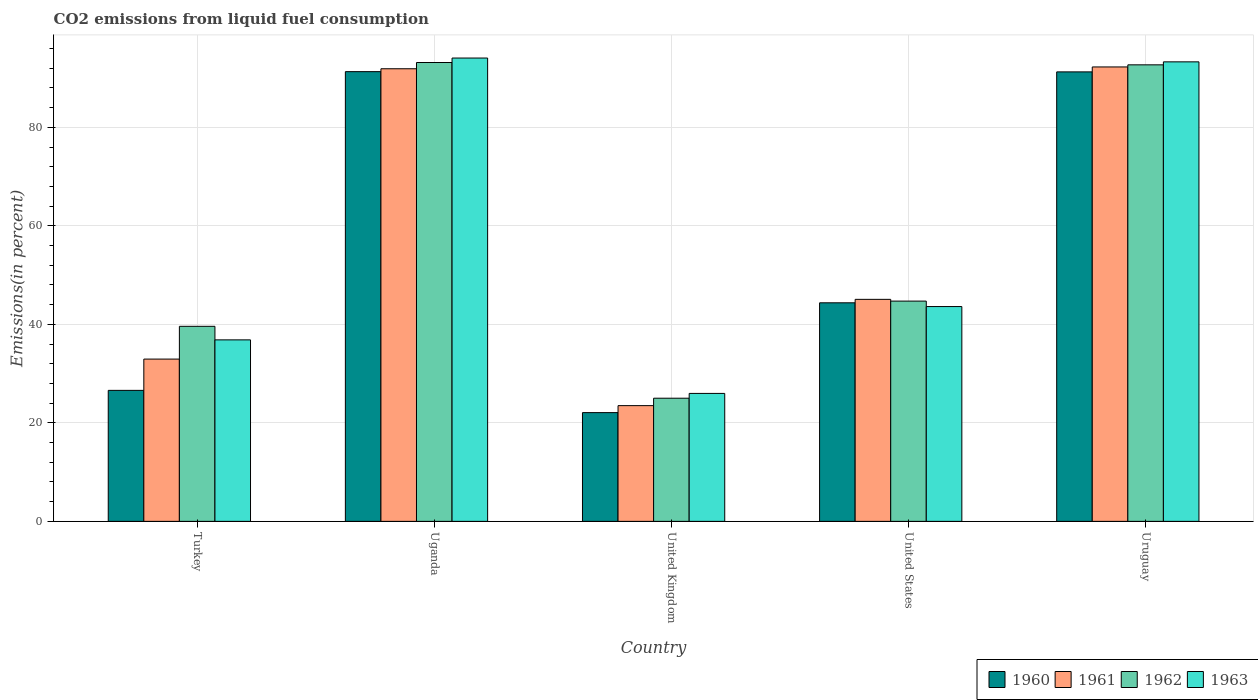How many different coloured bars are there?
Give a very brief answer. 4. Are the number of bars per tick equal to the number of legend labels?
Offer a very short reply. Yes. Are the number of bars on each tick of the X-axis equal?
Your answer should be compact. Yes. What is the label of the 2nd group of bars from the left?
Ensure brevity in your answer.  Uganda. What is the total CO2 emitted in 1963 in United Kingdom?
Your response must be concise. 25.98. Across all countries, what is the maximum total CO2 emitted in 1960?
Ensure brevity in your answer.  91.3. Across all countries, what is the minimum total CO2 emitted in 1963?
Ensure brevity in your answer.  25.98. In which country was the total CO2 emitted in 1961 maximum?
Give a very brief answer. Uruguay. In which country was the total CO2 emitted in 1960 minimum?
Your response must be concise. United Kingdom. What is the total total CO2 emitted in 1962 in the graph?
Ensure brevity in your answer.  295.17. What is the difference between the total CO2 emitted in 1960 in Turkey and that in Uganda?
Your response must be concise. -64.71. What is the difference between the total CO2 emitted in 1962 in Uganda and the total CO2 emitted in 1963 in Turkey?
Make the answer very short. 56.31. What is the average total CO2 emitted in 1963 per country?
Keep it short and to the point. 58.76. What is the difference between the total CO2 emitted of/in 1960 and total CO2 emitted of/in 1962 in Uganda?
Provide a short and direct response. -1.86. In how many countries, is the total CO2 emitted in 1960 greater than 68 %?
Give a very brief answer. 2. What is the ratio of the total CO2 emitted in 1963 in Uganda to that in Uruguay?
Keep it short and to the point. 1.01. Is the total CO2 emitted in 1960 in Uganda less than that in United States?
Provide a succinct answer. No. What is the difference between the highest and the second highest total CO2 emitted in 1962?
Offer a terse response. -0.48. What is the difference between the highest and the lowest total CO2 emitted in 1962?
Keep it short and to the point. 68.16. Is the sum of the total CO2 emitted in 1963 in Turkey and United Kingdom greater than the maximum total CO2 emitted in 1961 across all countries?
Your answer should be very brief. No. What does the 4th bar from the left in United Kingdom represents?
Your answer should be very brief. 1963. Is it the case that in every country, the sum of the total CO2 emitted in 1961 and total CO2 emitted in 1962 is greater than the total CO2 emitted in 1960?
Your response must be concise. Yes. How many bars are there?
Keep it short and to the point. 20. Are the values on the major ticks of Y-axis written in scientific E-notation?
Your response must be concise. No. Does the graph contain grids?
Your answer should be very brief. Yes. How many legend labels are there?
Your answer should be compact. 4. How are the legend labels stacked?
Keep it short and to the point. Horizontal. What is the title of the graph?
Make the answer very short. CO2 emissions from liquid fuel consumption. Does "2011" appear as one of the legend labels in the graph?
Your response must be concise. No. What is the label or title of the X-axis?
Provide a succinct answer. Country. What is the label or title of the Y-axis?
Ensure brevity in your answer.  Emissions(in percent). What is the Emissions(in percent) of 1960 in Turkey?
Your answer should be very brief. 26.6. What is the Emissions(in percent) of 1961 in Turkey?
Your answer should be compact. 32.95. What is the Emissions(in percent) of 1962 in Turkey?
Make the answer very short. 39.6. What is the Emissions(in percent) in 1963 in Turkey?
Offer a terse response. 36.85. What is the Emissions(in percent) in 1960 in Uganda?
Offer a very short reply. 91.3. What is the Emissions(in percent) of 1961 in Uganda?
Give a very brief answer. 91.89. What is the Emissions(in percent) in 1962 in Uganda?
Provide a short and direct response. 93.16. What is the Emissions(in percent) of 1963 in Uganda?
Offer a very short reply. 94.07. What is the Emissions(in percent) of 1960 in United Kingdom?
Ensure brevity in your answer.  22.08. What is the Emissions(in percent) in 1961 in United Kingdom?
Give a very brief answer. 23.5. What is the Emissions(in percent) in 1962 in United Kingdom?
Make the answer very short. 25.01. What is the Emissions(in percent) of 1963 in United Kingdom?
Make the answer very short. 25.98. What is the Emissions(in percent) in 1960 in United States?
Ensure brevity in your answer.  44.37. What is the Emissions(in percent) of 1961 in United States?
Your answer should be compact. 45.07. What is the Emissions(in percent) of 1962 in United States?
Provide a succinct answer. 44.72. What is the Emissions(in percent) in 1963 in United States?
Keep it short and to the point. 43.61. What is the Emissions(in percent) in 1960 in Uruguay?
Offer a terse response. 91.26. What is the Emissions(in percent) of 1961 in Uruguay?
Offer a terse response. 92.26. What is the Emissions(in percent) of 1962 in Uruguay?
Make the answer very short. 92.69. What is the Emissions(in percent) of 1963 in Uruguay?
Your answer should be compact. 93.29. Across all countries, what is the maximum Emissions(in percent) in 1960?
Your answer should be compact. 91.3. Across all countries, what is the maximum Emissions(in percent) in 1961?
Keep it short and to the point. 92.26. Across all countries, what is the maximum Emissions(in percent) in 1962?
Provide a succinct answer. 93.16. Across all countries, what is the maximum Emissions(in percent) of 1963?
Give a very brief answer. 94.07. Across all countries, what is the minimum Emissions(in percent) of 1960?
Give a very brief answer. 22.08. Across all countries, what is the minimum Emissions(in percent) in 1961?
Give a very brief answer. 23.5. Across all countries, what is the minimum Emissions(in percent) of 1962?
Provide a succinct answer. 25.01. Across all countries, what is the minimum Emissions(in percent) in 1963?
Make the answer very short. 25.98. What is the total Emissions(in percent) of 1960 in the graph?
Your response must be concise. 275.61. What is the total Emissions(in percent) of 1961 in the graph?
Provide a succinct answer. 285.67. What is the total Emissions(in percent) in 1962 in the graph?
Your response must be concise. 295.17. What is the total Emissions(in percent) in 1963 in the graph?
Provide a short and direct response. 293.8. What is the difference between the Emissions(in percent) in 1960 in Turkey and that in Uganda?
Your answer should be very brief. -64.71. What is the difference between the Emissions(in percent) of 1961 in Turkey and that in Uganda?
Keep it short and to the point. -58.95. What is the difference between the Emissions(in percent) of 1962 in Turkey and that in Uganda?
Provide a succinct answer. -53.56. What is the difference between the Emissions(in percent) in 1963 in Turkey and that in Uganda?
Give a very brief answer. -57.22. What is the difference between the Emissions(in percent) of 1960 in Turkey and that in United Kingdom?
Give a very brief answer. 4.52. What is the difference between the Emissions(in percent) of 1961 in Turkey and that in United Kingdom?
Your response must be concise. 9.45. What is the difference between the Emissions(in percent) in 1962 in Turkey and that in United Kingdom?
Offer a very short reply. 14.59. What is the difference between the Emissions(in percent) of 1963 in Turkey and that in United Kingdom?
Offer a terse response. 10.87. What is the difference between the Emissions(in percent) of 1960 in Turkey and that in United States?
Make the answer very short. -17.78. What is the difference between the Emissions(in percent) of 1961 in Turkey and that in United States?
Ensure brevity in your answer.  -12.13. What is the difference between the Emissions(in percent) in 1962 in Turkey and that in United States?
Offer a very short reply. -5.12. What is the difference between the Emissions(in percent) of 1963 in Turkey and that in United States?
Ensure brevity in your answer.  -6.76. What is the difference between the Emissions(in percent) of 1960 in Turkey and that in Uruguay?
Offer a terse response. -64.66. What is the difference between the Emissions(in percent) of 1961 in Turkey and that in Uruguay?
Provide a short and direct response. -59.31. What is the difference between the Emissions(in percent) in 1962 in Turkey and that in Uruguay?
Your answer should be very brief. -53.09. What is the difference between the Emissions(in percent) in 1963 in Turkey and that in Uruguay?
Offer a very short reply. -56.44. What is the difference between the Emissions(in percent) in 1960 in Uganda and that in United Kingdom?
Keep it short and to the point. 69.23. What is the difference between the Emissions(in percent) of 1961 in Uganda and that in United Kingdom?
Your response must be concise. 68.4. What is the difference between the Emissions(in percent) of 1962 in Uganda and that in United Kingdom?
Your answer should be very brief. 68.16. What is the difference between the Emissions(in percent) in 1963 in Uganda and that in United Kingdom?
Provide a succinct answer. 68.09. What is the difference between the Emissions(in percent) in 1960 in Uganda and that in United States?
Give a very brief answer. 46.93. What is the difference between the Emissions(in percent) in 1961 in Uganda and that in United States?
Provide a short and direct response. 46.82. What is the difference between the Emissions(in percent) of 1962 in Uganda and that in United States?
Your answer should be compact. 48.44. What is the difference between the Emissions(in percent) in 1963 in Uganda and that in United States?
Offer a very short reply. 50.46. What is the difference between the Emissions(in percent) in 1960 in Uganda and that in Uruguay?
Your answer should be very brief. 0.05. What is the difference between the Emissions(in percent) in 1961 in Uganda and that in Uruguay?
Make the answer very short. -0.37. What is the difference between the Emissions(in percent) in 1962 in Uganda and that in Uruguay?
Provide a succinct answer. 0.47. What is the difference between the Emissions(in percent) of 1963 in Uganda and that in Uruguay?
Ensure brevity in your answer.  0.77. What is the difference between the Emissions(in percent) of 1960 in United Kingdom and that in United States?
Your answer should be compact. -22.3. What is the difference between the Emissions(in percent) in 1961 in United Kingdom and that in United States?
Provide a succinct answer. -21.58. What is the difference between the Emissions(in percent) in 1962 in United Kingdom and that in United States?
Make the answer very short. -19.71. What is the difference between the Emissions(in percent) of 1963 in United Kingdom and that in United States?
Give a very brief answer. -17.63. What is the difference between the Emissions(in percent) of 1960 in United Kingdom and that in Uruguay?
Your answer should be very brief. -69.18. What is the difference between the Emissions(in percent) in 1961 in United Kingdom and that in Uruguay?
Give a very brief answer. -68.76. What is the difference between the Emissions(in percent) of 1962 in United Kingdom and that in Uruguay?
Give a very brief answer. -67.68. What is the difference between the Emissions(in percent) in 1963 in United Kingdom and that in Uruguay?
Provide a short and direct response. -67.32. What is the difference between the Emissions(in percent) of 1960 in United States and that in Uruguay?
Ensure brevity in your answer.  -46.88. What is the difference between the Emissions(in percent) of 1961 in United States and that in Uruguay?
Give a very brief answer. -47.19. What is the difference between the Emissions(in percent) in 1962 in United States and that in Uruguay?
Your answer should be very brief. -47.97. What is the difference between the Emissions(in percent) in 1963 in United States and that in Uruguay?
Your response must be concise. -49.68. What is the difference between the Emissions(in percent) of 1960 in Turkey and the Emissions(in percent) of 1961 in Uganda?
Your answer should be very brief. -65.3. What is the difference between the Emissions(in percent) in 1960 in Turkey and the Emissions(in percent) in 1962 in Uganda?
Your response must be concise. -66.57. What is the difference between the Emissions(in percent) in 1960 in Turkey and the Emissions(in percent) in 1963 in Uganda?
Your answer should be compact. -67.47. What is the difference between the Emissions(in percent) in 1961 in Turkey and the Emissions(in percent) in 1962 in Uganda?
Offer a terse response. -60.22. What is the difference between the Emissions(in percent) of 1961 in Turkey and the Emissions(in percent) of 1963 in Uganda?
Your answer should be compact. -61.12. What is the difference between the Emissions(in percent) in 1962 in Turkey and the Emissions(in percent) in 1963 in Uganda?
Keep it short and to the point. -54.47. What is the difference between the Emissions(in percent) of 1960 in Turkey and the Emissions(in percent) of 1961 in United Kingdom?
Your answer should be compact. 3.1. What is the difference between the Emissions(in percent) in 1960 in Turkey and the Emissions(in percent) in 1962 in United Kingdom?
Offer a terse response. 1.59. What is the difference between the Emissions(in percent) in 1960 in Turkey and the Emissions(in percent) in 1963 in United Kingdom?
Your answer should be compact. 0.62. What is the difference between the Emissions(in percent) in 1961 in Turkey and the Emissions(in percent) in 1962 in United Kingdom?
Offer a very short reply. 7.94. What is the difference between the Emissions(in percent) in 1961 in Turkey and the Emissions(in percent) in 1963 in United Kingdom?
Your answer should be compact. 6.97. What is the difference between the Emissions(in percent) of 1962 in Turkey and the Emissions(in percent) of 1963 in United Kingdom?
Offer a terse response. 13.62. What is the difference between the Emissions(in percent) in 1960 in Turkey and the Emissions(in percent) in 1961 in United States?
Keep it short and to the point. -18.48. What is the difference between the Emissions(in percent) in 1960 in Turkey and the Emissions(in percent) in 1962 in United States?
Provide a succinct answer. -18.12. What is the difference between the Emissions(in percent) of 1960 in Turkey and the Emissions(in percent) of 1963 in United States?
Offer a very short reply. -17.02. What is the difference between the Emissions(in percent) of 1961 in Turkey and the Emissions(in percent) of 1962 in United States?
Your answer should be compact. -11.77. What is the difference between the Emissions(in percent) of 1961 in Turkey and the Emissions(in percent) of 1963 in United States?
Your answer should be very brief. -10.67. What is the difference between the Emissions(in percent) of 1962 in Turkey and the Emissions(in percent) of 1963 in United States?
Provide a succinct answer. -4.01. What is the difference between the Emissions(in percent) in 1960 in Turkey and the Emissions(in percent) in 1961 in Uruguay?
Provide a short and direct response. -65.66. What is the difference between the Emissions(in percent) of 1960 in Turkey and the Emissions(in percent) of 1962 in Uruguay?
Ensure brevity in your answer.  -66.09. What is the difference between the Emissions(in percent) of 1960 in Turkey and the Emissions(in percent) of 1963 in Uruguay?
Your response must be concise. -66.7. What is the difference between the Emissions(in percent) of 1961 in Turkey and the Emissions(in percent) of 1962 in Uruguay?
Ensure brevity in your answer.  -59.74. What is the difference between the Emissions(in percent) in 1961 in Turkey and the Emissions(in percent) in 1963 in Uruguay?
Offer a terse response. -60.35. What is the difference between the Emissions(in percent) of 1962 in Turkey and the Emissions(in percent) of 1963 in Uruguay?
Your response must be concise. -53.69. What is the difference between the Emissions(in percent) of 1960 in Uganda and the Emissions(in percent) of 1961 in United Kingdom?
Your response must be concise. 67.81. What is the difference between the Emissions(in percent) in 1960 in Uganda and the Emissions(in percent) in 1962 in United Kingdom?
Offer a terse response. 66.3. What is the difference between the Emissions(in percent) of 1960 in Uganda and the Emissions(in percent) of 1963 in United Kingdom?
Your answer should be very brief. 65.33. What is the difference between the Emissions(in percent) of 1961 in Uganda and the Emissions(in percent) of 1962 in United Kingdom?
Offer a terse response. 66.89. What is the difference between the Emissions(in percent) in 1961 in Uganda and the Emissions(in percent) in 1963 in United Kingdom?
Make the answer very short. 65.91. What is the difference between the Emissions(in percent) of 1962 in Uganda and the Emissions(in percent) of 1963 in United Kingdom?
Offer a very short reply. 67.18. What is the difference between the Emissions(in percent) in 1960 in Uganda and the Emissions(in percent) in 1961 in United States?
Your answer should be compact. 46.23. What is the difference between the Emissions(in percent) of 1960 in Uganda and the Emissions(in percent) of 1962 in United States?
Provide a short and direct response. 46.59. What is the difference between the Emissions(in percent) in 1960 in Uganda and the Emissions(in percent) in 1963 in United States?
Provide a succinct answer. 47.69. What is the difference between the Emissions(in percent) of 1961 in Uganda and the Emissions(in percent) of 1962 in United States?
Give a very brief answer. 47.17. What is the difference between the Emissions(in percent) of 1961 in Uganda and the Emissions(in percent) of 1963 in United States?
Give a very brief answer. 48.28. What is the difference between the Emissions(in percent) in 1962 in Uganda and the Emissions(in percent) in 1963 in United States?
Make the answer very short. 49.55. What is the difference between the Emissions(in percent) of 1960 in Uganda and the Emissions(in percent) of 1961 in Uruguay?
Keep it short and to the point. -0.96. What is the difference between the Emissions(in percent) in 1960 in Uganda and the Emissions(in percent) in 1962 in Uruguay?
Offer a terse response. -1.38. What is the difference between the Emissions(in percent) of 1960 in Uganda and the Emissions(in percent) of 1963 in Uruguay?
Keep it short and to the point. -1.99. What is the difference between the Emissions(in percent) of 1961 in Uganda and the Emissions(in percent) of 1962 in Uruguay?
Keep it short and to the point. -0.8. What is the difference between the Emissions(in percent) of 1961 in Uganda and the Emissions(in percent) of 1963 in Uruguay?
Give a very brief answer. -1.4. What is the difference between the Emissions(in percent) of 1962 in Uganda and the Emissions(in percent) of 1963 in Uruguay?
Provide a short and direct response. -0.13. What is the difference between the Emissions(in percent) in 1960 in United Kingdom and the Emissions(in percent) in 1961 in United States?
Offer a very short reply. -23. What is the difference between the Emissions(in percent) of 1960 in United Kingdom and the Emissions(in percent) of 1962 in United States?
Offer a very short reply. -22.64. What is the difference between the Emissions(in percent) of 1960 in United Kingdom and the Emissions(in percent) of 1963 in United States?
Make the answer very short. -21.54. What is the difference between the Emissions(in percent) in 1961 in United Kingdom and the Emissions(in percent) in 1962 in United States?
Make the answer very short. -21.22. What is the difference between the Emissions(in percent) in 1961 in United Kingdom and the Emissions(in percent) in 1963 in United States?
Ensure brevity in your answer.  -20.12. What is the difference between the Emissions(in percent) of 1962 in United Kingdom and the Emissions(in percent) of 1963 in United States?
Offer a very short reply. -18.61. What is the difference between the Emissions(in percent) of 1960 in United Kingdom and the Emissions(in percent) of 1961 in Uruguay?
Offer a terse response. -70.18. What is the difference between the Emissions(in percent) in 1960 in United Kingdom and the Emissions(in percent) in 1962 in Uruguay?
Your answer should be compact. -70.61. What is the difference between the Emissions(in percent) in 1960 in United Kingdom and the Emissions(in percent) in 1963 in Uruguay?
Make the answer very short. -71.22. What is the difference between the Emissions(in percent) in 1961 in United Kingdom and the Emissions(in percent) in 1962 in Uruguay?
Ensure brevity in your answer.  -69.19. What is the difference between the Emissions(in percent) of 1961 in United Kingdom and the Emissions(in percent) of 1963 in Uruguay?
Make the answer very short. -69.8. What is the difference between the Emissions(in percent) of 1962 in United Kingdom and the Emissions(in percent) of 1963 in Uruguay?
Your answer should be compact. -68.29. What is the difference between the Emissions(in percent) in 1960 in United States and the Emissions(in percent) in 1961 in Uruguay?
Provide a short and direct response. -47.89. What is the difference between the Emissions(in percent) in 1960 in United States and the Emissions(in percent) in 1962 in Uruguay?
Provide a succinct answer. -48.31. What is the difference between the Emissions(in percent) of 1960 in United States and the Emissions(in percent) of 1963 in Uruguay?
Make the answer very short. -48.92. What is the difference between the Emissions(in percent) of 1961 in United States and the Emissions(in percent) of 1962 in Uruguay?
Provide a short and direct response. -47.61. What is the difference between the Emissions(in percent) in 1961 in United States and the Emissions(in percent) in 1963 in Uruguay?
Your answer should be very brief. -48.22. What is the difference between the Emissions(in percent) of 1962 in United States and the Emissions(in percent) of 1963 in Uruguay?
Offer a very short reply. -48.58. What is the average Emissions(in percent) of 1960 per country?
Provide a succinct answer. 55.12. What is the average Emissions(in percent) in 1961 per country?
Keep it short and to the point. 57.13. What is the average Emissions(in percent) of 1962 per country?
Your response must be concise. 59.03. What is the average Emissions(in percent) in 1963 per country?
Keep it short and to the point. 58.76. What is the difference between the Emissions(in percent) of 1960 and Emissions(in percent) of 1961 in Turkey?
Your answer should be compact. -6.35. What is the difference between the Emissions(in percent) of 1960 and Emissions(in percent) of 1962 in Turkey?
Provide a short and direct response. -13. What is the difference between the Emissions(in percent) in 1960 and Emissions(in percent) in 1963 in Turkey?
Keep it short and to the point. -10.25. What is the difference between the Emissions(in percent) of 1961 and Emissions(in percent) of 1962 in Turkey?
Your answer should be very brief. -6.65. What is the difference between the Emissions(in percent) in 1961 and Emissions(in percent) in 1963 in Turkey?
Offer a very short reply. -3.9. What is the difference between the Emissions(in percent) in 1962 and Emissions(in percent) in 1963 in Turkey?
Your answer should be very brief. 2.75. What is the difference between the Emissions(in percent) in 1960 and Emissions(in percent) in 1961 in Uganda?
Provide a short and direct response. -0.59. What is the difference between the Emissions(in percent) in 1960 and Emissions(in percent) in 1962 in Uganda?
Ensure brevity in your answer.  -1.86. What is the difference between the Emissions(in percent) in 1960 and Emissions(in percent) in 1963 in Uganda?
Give a very brief answer. -2.76. What is the difference between the Emissions(in percent) in 1961 and Emissions(in percent) in 1962 in Uganda?
Offer a terse response. -1.27. What is the difference between the Emissions(in percent) in 1961 and Emissions(in percent) in 1963 in Uganda?
Your answer should be compact. -2.18. What is the difference between the Emissions(in percent) of 1962 and Emissions(in percent) of 1963 in Uganda?
Give a very brief answer. -0.91. What is the difference between the Emissions(in percent) of 1960 and Emissions(in percent) of 1961 in United Kingdom?
Keep it short and to the point. -1.42. What is the difference between the Emissions(in percent) in 1960 and Emissions(in percent) in 1962 in United Kingdom?
Ensure brevity in your answer.  -2.93. What is the difference between the Emissions(in percent) in 1960 and Emissions(in percent) in 1963 in United Kingdom?
Your answer should be compact. -3.9. What is the difference between the Emissions(in percent) of 1961 and Emissions(in percent) of 1962 in United Kingdom?
Provide a succinct answer. -1.51. What is the difference between the Emissions(in percent) of 1961 and Emissions(in percent) of 1963 in United Kingdom?
Offer a terse response. -2.48. What is the difference between the Emissions(in percent) of 1962 and Emissions(in percent) of 1963 in United Kingdom?
Offer a terse response. -0.97. What is the difference between the Emissions(in percent) of 1960 and Emissions(in percent) of 1961 in United States?
Provide a short and direct response. -0.7. What is the difference between the Emissions(in percent) in 1960 and Emissions(in percent) in 1962 in United States?
Make the answer very short. -0.35. What is the difference between the Emissions(in percent) of 1960 and Emissions(in percent) of 1963 in United States?
Offer a very short reply. 0.76. What is the difference between the Emissions(in percent) in 1961 and Emissions(in percent) in 1962 in United States?
Provide a short and direct response. 0.36. What is the difference between the Emissions(in percent) in 1961 and Emissions(in percent) in 1963 in United States?
Provide a succinct answer. 1.46. What is the difference between the Emissions(in percent) of 1962 and Emissions(in percent) of 1963 in United States?
Give a very brief answer. 1.11. What is the difference between the Emissions(in percent) in 1960 and Emissions(in percent) in 1961 in Uruguay?
Keep it short and to the point. -1. What is the difference between the Emissions(in percent) in 1960 and Emissions(in percent) in 1962 in Uruguay?
Your answer should be compact. -1.43. What is the difference between the Emissions(in percent) of 1960 and Emissions(in percent) of 1963 in Uruguay?
Provide a short and direct response. -2.04. What is the difference between the Emissions(in percent) of 1961 and Emissions(in percent) of 1962 in Uruguay?
Offer a very short reply. -0.43. What is the difference between the Emissions(in percent) in 1961 and Emissions(in percent) in 1963 in Uruguay?
Your answer should be very brief. -1.03. What is the difference between the Emissions(in percent) in 1962 and Emissions(in percent) in 1963 in Uruguay?
Your answer should be compact. -0.61. What is the ratio of the Emissions(in percent) in 1960 in Turkey to that in Uganda?
Ensure brevity in your answer.  0.29. What is the ratio of the Emissions(in percent) in 1961 in Turkey to that in Uganda?
Keep it short and to the point. 0.36. What is the ratio of the Emissions(in percent) in 1962 in Turkey to that in Uganda?
Keep it short and to the point. 0.43. What is the ratio of the Emissions(in percent) in 1963 in Turkey to that in Uganda?
Ensure brevity in your answer.  0.39. What is the ratio of the Emissions(in percent) of 1960 in Turkey to that in United Kingdom?
Keep it short and to the point. 1.2. What is the ratio of the Emissions(in percent) of 1961 in Turkey to that in United Kingdom?
Make the answer very short. 1.4. What is the ratio of the Emissions(in percent) in 1962 in Turkey to that in United Kingdom?
Your answer should be very brief. 1.58. What is the ratio of the Emissions(in percent) in 1963 in Turkey to that in United Kingdom?
Offer a very short reply. 1.42. What is the ratio of the Emissions(in percent) in 1960 in Turkey to that in United States?
Offer a terse response. 0.6. What is the ratio of the Emissions(in percent) of 1961 in Turkey to that in United States?
Provide a succinct answer. 0.73. What is the ratio of the Emissions(in percent) in 1962 in Turkey to that in United States?
Keep it short and to the point. 0.89. What is the ratio of the Emissions(in percent) of 1963 in Turkey to that in United States?
Your answer should be very brief. 0.84. What is the ratio of the Emissions(in percent) in 1960 in Turkey to that in Uruguay?
Make the answer very short. 0.29. What is the ratio of the Emissions(in percent) in 1961 in Turkey to that in Uruguay?
Keep it short and to the point. 0.36. What is the ratio of the Emissions(in percent) in 1962 in Turkey to that in Uruguay?
Your answer should be compact. 0.43. What is the ratio of the Emissions(in percent) in 1963 in Turkey to that in Uruguay?
Your response must be concise. 0.4. What is the ratio of the Emissions(in percent) in 1960 in Uganda to that in United Kingdom?
Make the answer very short. 4.14. What is the ratio of the Emissions(in percent) in 1961 in Uganda to that in United Kingdom?
Provide a short and direct response. 3.91. What is the ratio of the Emissions(in percent) in 1962 in Uganda to that in United Kingdom?
Make the answer very short. 3.73. What is the ratio of the Emissions(in percent) of 1963 in Uganda to that in United Kingdom?
Offer a very short reply. 3.62. What is the ratio of the Emissions(in percent) in 1960 in Uganda to that in United States?
Ensure brevity in your answer.  2.06. What is the ratio of the Emissions(in percent) in 1961 in Uganda to that in United States?
Give a very brief answer. 2.04. What is the ratio of the Emissions(in percent) of 1962 in Uganda to that in United States?
Give a very brief answer. 2.08. What is the ratio of the Emissions(in percent) in 1963 in Uganda to that in United States?
Keep it short and to the point. 2.16. What is the ratio of the Emissions(in percent) in 1962 in Uganda to that in Uruguay?
Your answer should be very brief. 1.01. What is the ratio of the Emissions(in percent) of 1963 in Uganda to that in Uruguay?
Your response must be concise. 1.01. What is the ratio of the Emissions(in percent) in 1960 in United Kingdom to that in United States?
Your response must be concise. 0.5. What is the ratio of the Emissions(in percent) in 1961 in United Kingdom to that in United States?
Provide a short and direct response. 0.52. What is the ratio of the Emissions(in percent) in 1962 in United Kingdom to that in United States?
Offer a very short reply. 0.56. What is the ratio of the Emissions(in percent) in 1963 in United Kingdom to that in United States?
Your response must be concise. 0.6. What is the ratio of the Emissions(in percent) in 1960 in United Kingdom to that in Uruguay?
Provide a succinct answer. 0.24. What is the ratio of the Emissions(in percent) of 1961 in United Kingdom to that in Uruguay?
Make the answer very short. 0.25. What is the ratio of the Emissions(in percent) in 1962 in United Kingdom to that in Uruguay?
Offer a terse response. 0.27. What is the ratio of the Emissions(in percent) of 1963 in United Kingdom to that in Uruguay?
Your answer should be compact. 0.28. What is the ratio of the Emissions(in percent) in 1960 in United States to that in Uruguay?
Your response must be concise. 0.49. What is the ratio of the Emissions(in percent) of 1961 in United States to that in Uruguay?
Keep it short and to the point. 0.49. What is the ratio of the Emissions(in percent) of 1962 in United States to that in Uruguay?
Provide a succinct answer. 0.48. What is the ratio of the Emissions(in percent) of 1963 in United States to that in Uruguay?
Your answer should be very brief. 0.47. What is the difference between the highest and the second highest Emissions(in percent) in 1960?
Make the answer very short. 0.05. What is the difference between the highest and the second highest Emissions(in percent) in 1961?
Your response must be concise. 0.37. What is the difference between the highest and the second highest Emissions(in percent) in 1962?
Offer a terse response. 0.47. What is the difference between the highest and the second highest Emissions(in percent) of 1963?
Ensure brevity in your answer.  0.77. What is the difference between the highest and the lowest Emissions(in percent) of 1960?
Keep it short and to the point. 69.23. What is the difference between the highest and the lowest Emissions(in percent) in 1961?
Your answer should be very brief. 68.76. What is the difference between the highest and the lowest Emissions(in percent) of 1962?
Give a very brief answer. 68.16. What is the difference between the highest and the lowest Emissions(in percent) in 1963?
Give a very brief answer. 68.09. 